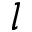<formula> <loc_0><loc_0><loc_500><loc_500>l</formula> 